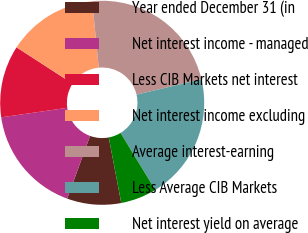Convert chart to OTSL. <chart><loc_0><loc_0><loc_500><loc_500><pie_chart><fcel>Year ended December 31 (in<fcel>Net interest income - managed<fcel>Less CIB Markets net interest<fcel>Net interest income excluding<fcel>Average interest-earning<fcel>Less Average CIB Markets<fcel>Net interest yield on average<nl><fcel>8.57%<fcel>17.14%<fcel>11.43%<fcel>14.29%<fcel>22.86%<fcel>20.0%<fcel>5.71%<nl></chart> 